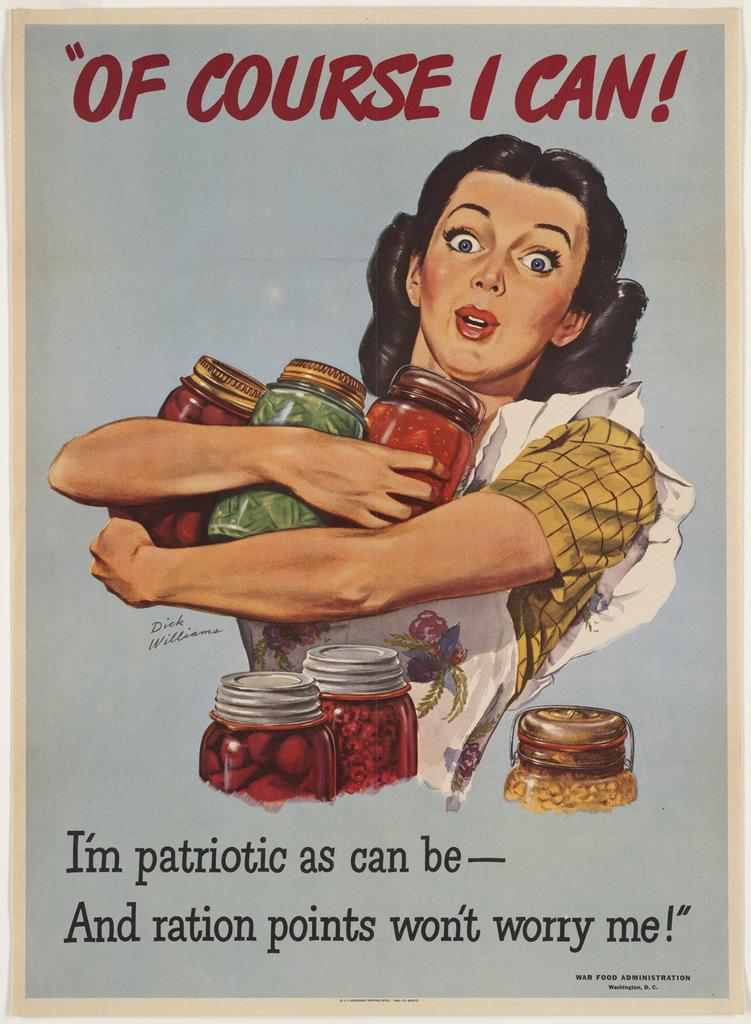Provide a one-sentence caption for the provided image. A woman proudly holds her jars of home canned produce, while saying, "Of course I can!". 